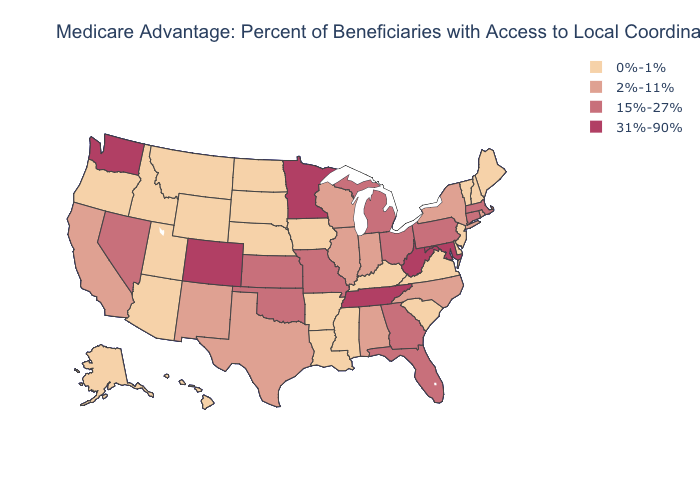Is the legend a continuous bar?
Quick response, please. No. Does South Carolina have a lower value than Arkansas?
Be succinct. No. Does Arizona have a lower value than New Hampshire?
Give a very brief answer. No. What is the highest value in states that border South Carolina?
Write a very short answer. 15%-27%. Name the states that have a value in the range 2%-11%?
Give a very brief answer. Alabama, California, Illinois, Indiana, North Carolina, New Mexico, New York, Rhode Island, Texas, Wisconsin. What is the lowest value in the West?
Write a very short answer. 0%-1%. What is the lowest value in the South?
Short answer required. 0%-1%. How many symbols are there in the legend?
Be succinct. 4. Does New Mexico have a lower value than Massachusetts?
Be succinct. Yes. Which states have the highest value in the USA?
Quick response, please. Colorado, Maryland, Minnesota, Tennessee, Washington, West Virginia. Name the states that have a value in the range 31%-90%?
Be succinct. Colorado, Maryland, Minnesota, Tennessee, Washington, West Virginia. How many symbols are there in the legend?
Be succinct. 4. Which states have the lowest value in the West?
Concise answer only. Alaska, Arizona, Hawaii, Idaho, Montana, Oregon, Utah, Wyoming. What is the value of Minnesota?
Answer briefly. 31%-90%. 